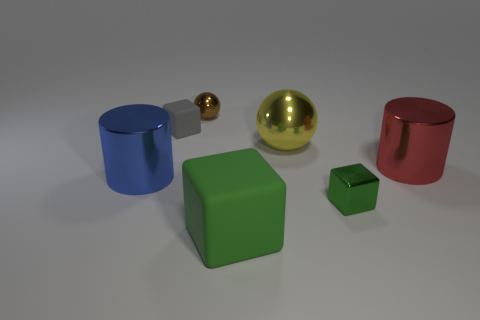Is there a tiny brown thing that has the same material as the red cylinder?
Provide a short and direct response. Yes. Is there a blue metal cylinder that is behind the small block that is behind the cylinder that is behind the blue metal cylinder?
Provide a succinct answer. No. What number of other objects are there of the same shape as the brown metal object?
Give a very brief answer. 1. The metallic cylinder behind the big cylinder to the left of the matte object in front of the big red cylinder is what color?
Provide a succinct answer. Red. What number of big brown metal objects are there?
Your answer should be very brief. 0. What number of big things are either gray balls or yellow shiny spheres?
Your response must be concise. 1. The yellow metallic thing that is the same size as the green matte block is what shape?
Your answer should be compact. Sphere. Is there anything else that has the same size as the red cylinder?
Provide a short and direct response. Yes. What is the material of the cube that is behind the tiny object to the right of the small brown object?
Your response must be concise. Rubber. Does the red thing have the same size as the gray block?
Provide a short and direct response. No. 